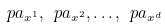<formula> <loc_0><loc_0><loc_500><loc_500>\ p a _ { x ^ { 1 } } , \ p a _ { x ^ { 2 } } , \dots , \ p a _ { x ^ { d } }</formula> 